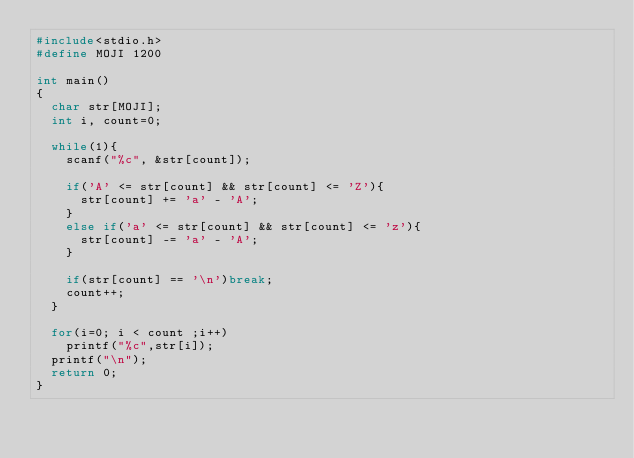<code> <loc_0><loc_0><loc_500><loc_500><_C_>#include<stdio.h>
#define MOJI 1200
  
int main()
{
  char str[MOJI];
  int i, count=0;
  
  while(1){
    scanf("%c", &str[count]);
  
    if('A' <= str[count] && str[count] <= 'Z'){
      str[count] += 'a' - 'A';
    }
    else if('a' <= str[count] && str[count] <= 'z'){
      str[count] -= 'a' - 'A';
    }
  
    if(str[count] == '\n')break;
    count++;
  }
  
  for(i=0; i < count ;i++)
    printf("%c",str[i]);
  printf("\n");
  return 0;
}
</code> 